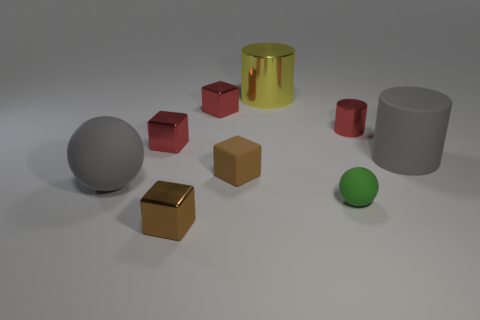Add 1 brown objects. How many objects exist? 10 Subtract all balls. How many objects are left? 7 Subtract all red objects. Subtract all brown matte things. How many objects are left? 5 Add 8 green matte balls. How many green matte balls are left? 9 Add 9 large yellow shiny cylinders. How many large yellow shiny cylinders exist? 10 Subtract 0 blue cubes. How many objects are left? 9 